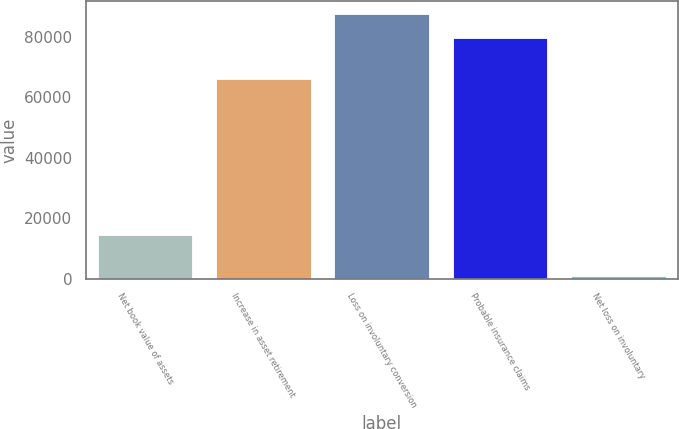Convert chart. <chart><loc_0><loc_0><loc_500><loc_500><bar_chart><fcel>Net book value of assets<fcel>Increase in asset retirement<fcel>Loss on involuntary conversion<fcel>Probable insurance claims<fcel>Net loss on involuntary<nl><fcel>14500<fcel>66000<fcel>87450<fcel>79500<fcel>1000<nl></chart> 